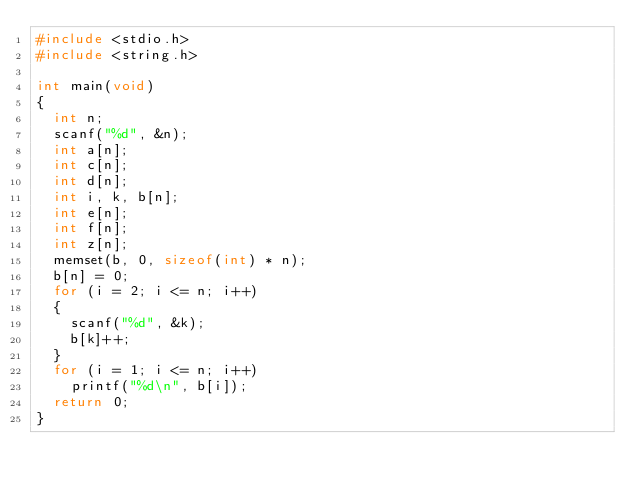<code> <loc_0><loc_0><loc_500><loc_500><_C_>#include <stdio.h>
#include <string.h>

int main(void)
{
  int n;
  scanf("%d", &n);
  int a[n];
  int c[n];
  int d[n];
  int i, k, b[n];
  int e[n];
  int f[n];
  int z[n];
  memset(b, 0, sizeof(int) * n);
  b[n] = 0;
  for (i = 2; i <= n; i++)
  {
    scanf("%d", &k);
    b[k]++;
  }
  for (i = 1; i <= n; i++)
    printf("%d\n", b[i]); 
  return 0;
}</code> 